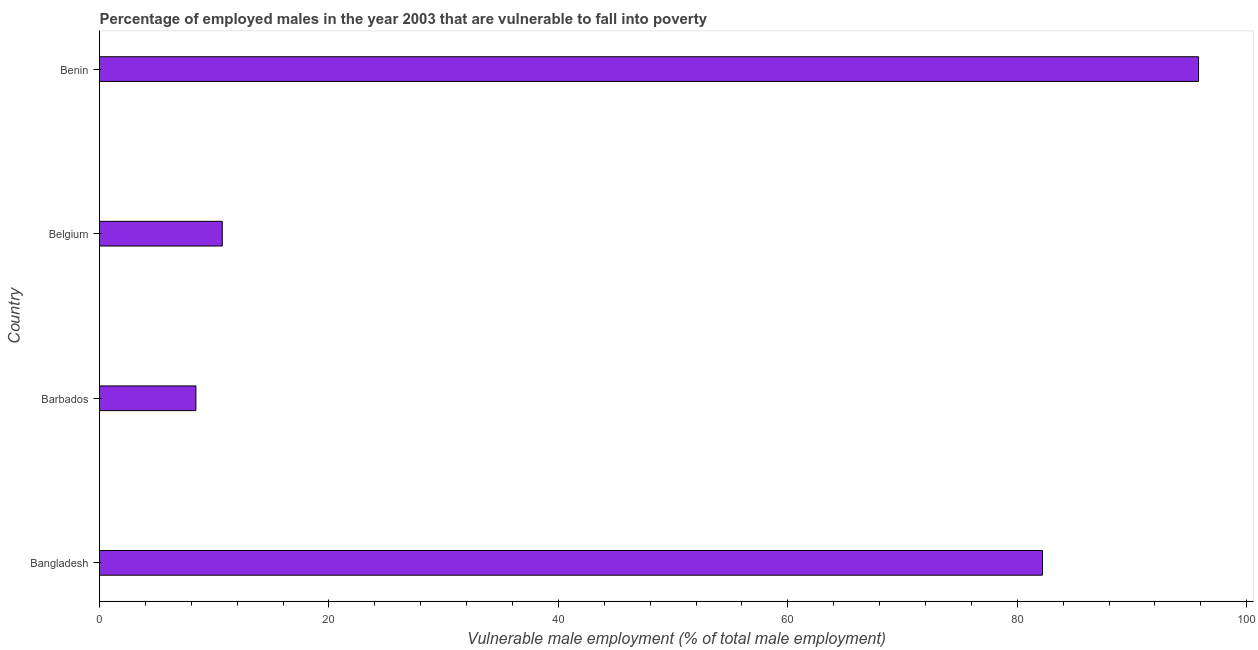Does the graph contain grids?
Make the answer very short. No. What is the title of the graph?
Your answer should be compact. Percentage of employed males in the year 2003 that are vulnerable to fall into poverty. What is the label or title of the X-axis?
Your answer should be very brief. Vulnerable male employment (% of total male employment). What is the label or title of the Y-axis?
Make the answer very short. Country. What is the percentage of employed males who are vulnerable to fall into poverty in Bangladesh?
Offer a very short reply. 82.2. Across all countries, what is the maximum percentage of employed males who are vulnerable to fall into poverty?
Your answer should be very brief. 95.8. Across all countries, what is the minimum percentage of employed males who are vulnerable to fall into poverty?
Your response must be concise. 8.4. In which country was the percentage of employed males who are vulnerable to fall into poverty maximum?
Make the answer very short. Benin. In which country was the percentage of employed males who are vulnerable to fall into poverty minimum?
Your response must be concise. Barbados. What is the sum of the percentage of employed males who are vulnerable to fall into poverty?
Offer a very short reply. 197.1. What is the difference between the percentage of employed males who are vulnerable to fall into poverty in Bangladesh and Barbados?
Offer a very short reply. 73.8. What is the average percentage of employed males who are vulnerable to fall into poverty per country?
Offer a terse response. 49.27. What is the median percentage of employed males who are vulnerable to fall into poverty?
Your answer should be compact. 46.45. In how many countries, is the percentage of employed males who are vulnerable to fall into poverty greater than 56 %?
Offer a terse response. 2. What is the ratio of the percentage of employed males who are vulnerable to fall into poverty in Barbados to that in Belgium?
Give a very brief answer. 0.79. What is the difference between the highest and the lowest percentage of employed males who are vulnerable to fall into poverty?
Keep it short and to the point. 87.4. How many bars are there?
Offer a terse response. 4. Are all the bars in the graph horizontal?
Make the answer very short. Yes. How many countries are there in the graph?
Provide a succinct answer. 4. What is the difference between two consecutive major ticks on the X-axis?
Keep it short and to the point. 20. What is the Vulnerable male employment (% of total male employment) of Bangladesh?
Your answer should be compact. 82.2. What is the Vulnerable male employment (% of total male employment) of Barbados?
Your answer should be very brief. 8.4. What is the Vulnerable male employment (% of total male employment) in Belgium?
Offer a terse response. 10.7. What is the Vulnerable male employment (% of total male employment) in Benin?
Offer a very short reply. 95.8. What is the difference between the Vulnerable male employment (% of total male employment) in Bangladesh and Barbados?
Offer a terse response. 73.8. What is the difference between the Vulnerable male employment (% of total male employment) in Bangladesh and Belgium?
Offer a very short reply. 71.5. What is the difference between the Vulnerable male employment (% of total male employment) in Bangladesh and Benin?
Provide a succinct answer. -13.6. What is the difference between the Vulnerable male employment (% of total male employment) in Barbados and Belgium?
Your answer should be compact. -2.3. What is the difference between the Vulnerable male employment (% of total male employment) in Barbados and Benin?
Offer a terse response. -87.4. What is the difference between the Vulnerable male employment (% of total male employment) in Belgium and Benin?
Give a very brief answer. -85.1. What is the ratio of the Vulnerable male employment (% of total male employment) in Bangladesh to that in Barbados?
Your answer should be compact. 9.79. What is the ratio of the Vulnerable male employment (% of total male employment) in Bangladesh to that in Belgium?
Your response must be concise. 7.68. What is the ratio of the Vulnerable male employment (% of total male employment) in Bangladesh to that in Benin?
Make the answer very short. 0.86. What is the ratio of the Vulnerable male employment (% of total male employment) in Barbados to that in Belgium?
Your answer should be compact. 0.79. What is the ratio of the Vulnerable male employment (% of total male employment) in Barbados to that in Benin?
Offer a very short reply. 0.09. What is the ratio of the Vulnerable male employment (% of total male employment) in Belgium to that in Benin?
Provide a short and direct response. 0.11. 